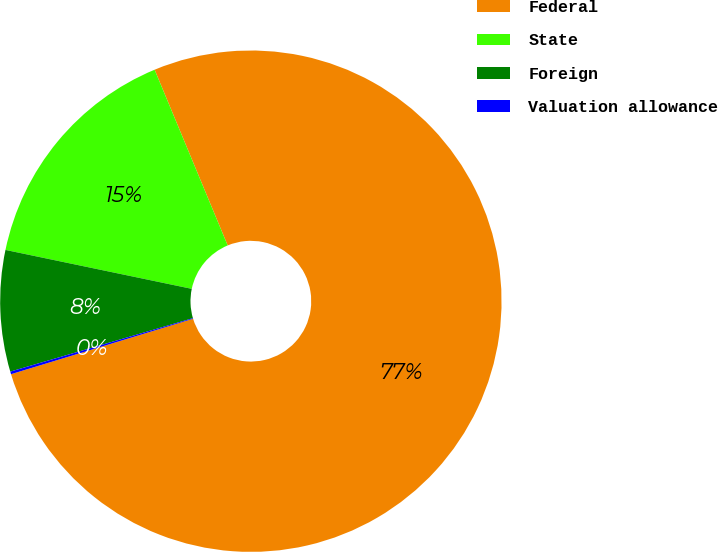Convert chart to OTSL. <chart><loc_0><loc_0><loc_500><loc_500><pie_chart><fcel>Federal<fcel>State<fcel>Foreign<fcel>Valuation allowance<nl><fcel>76.57%<fcel>15.45%<fcel>7.81%<fcel>0.17%<nl></chart> 